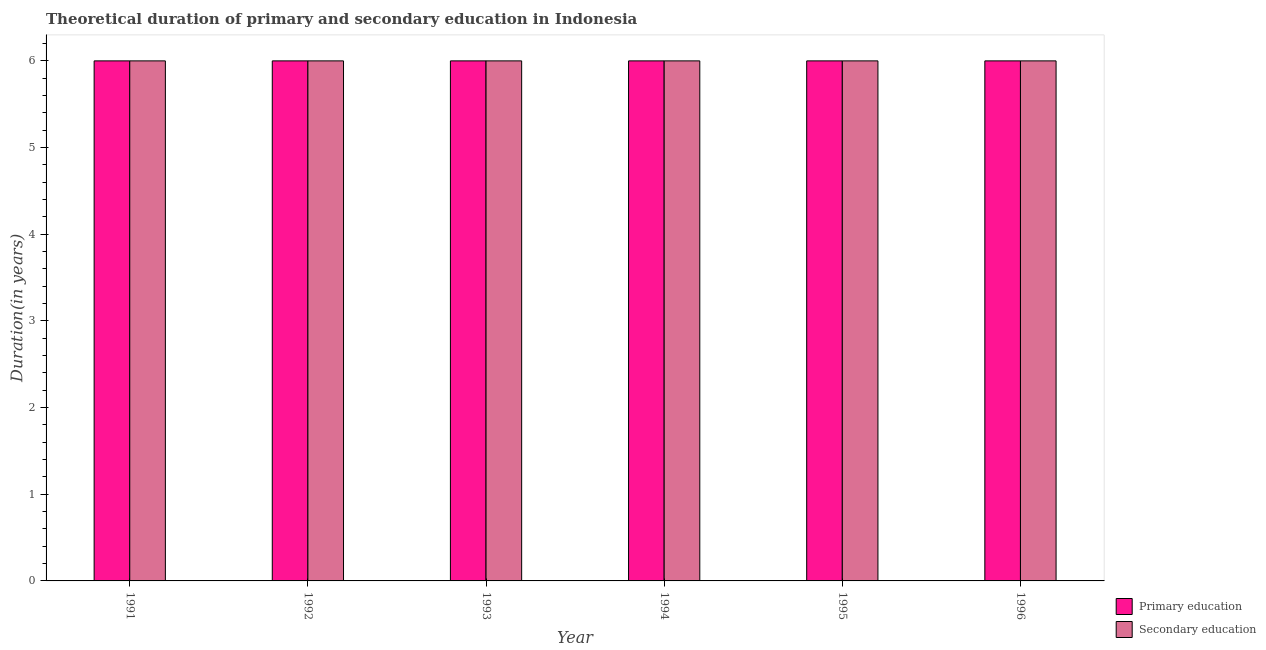How many groups of bars are there?
Keep it short and to the point. 6. Are the number of bars per tick equal to the number of legend labels?
Offer a very short reply. Yes. Are the number of bars on each tick of the X-axis equal?
Your answer should be compact. Yes. What is the label of the 5th group of bars from the left?
Your answer should be compact. 1995. Across all years, what is the maximum duration of secondary education?
Your answer should be very brief. 6. Across all years, what is the minimum duration of secondary education?
Provide a short and direct response. 6. In which year was the duration of primary education maximum?
Your response must be concise. 1991. In which year was the duration of secondary education minimum?
Offer a terse response. 1991. What is the total duration of secondary education in the graph?
Provide a succinct answer. 36. What is the difference between the duration of secondary education in 1995 and that in 1996?
Provide a succinct answer. 0. In how many years, is the duration of secondary education greater than 3.2 years?
Give a very brief answer. 6. What is the difference between the highest and the second highest duration of primary education?
Ensure brevity in your answer.  0. What is the difference between the highest and the lowest duration of primary education?
Ensure brevity in your answer.  0. In how many years, is the duration of primary education greater than the average duration of primary education taken over all years?
Your answer should be compact. 0. What does the 2nd bar from the left in 1992 represents?
Ensure brevity in your answer.  Secondary education. What does the 2nd bar from the right in 1992 represents?
Your answer should be very brief. Primary education. How many bars are there?
Your answer should be compact. 12. How many years are there in the graph?
Give a very brief answer. 6. What is the difference between two consecutive major ticks on the Y-axis?
Your answer should be compact. 1. Does the graph contain grids?
Make the answer very short. No. Where does the legend appear in the graph?
Give a very brief answer. Bottom right. How many legend labels are there?
Your response must be concise. 2. How are the legend labels stacked?
Ensure brevity in your answer.  Vertical. What is the title of the graph?
Keep it short and to the point. Theoretical duration of primary and secondary education in Indonesia. Does "Official creditors" appear as one of the legend labels in the graph?
Provide a succinct answer. No. What is the label or title of the X-axis?
Keep it short and to the point. Year. What is the label or title of the Y-axis?
Keep it short and to the point. Duration(in years). What is the Duration(in years) in Secondary education in 1991?
Give a very brief answer. 6. What is the Duration(in years) in Primary education in 1992?
Ensure brevity in your answer.  6. What is the Duration(in years) in Primary education in 1994?
Your answer should be very brief. 6. What is the Duration(in years) of Secondary education in 1994?
Offer a very short reply. 6. What is the Duration(in years) of Secondary education in 1995?
Make the answer very short. 6. What is the Duration(in years) of Primary education in 1996?
Give a very brief answer. 6. What is the Duration(in years) of Secondary education in 1996?
Provide a short and direct response. 6. Across all years, what is the maximum Duration(in years) in Primary education?
Your answer should be compact. 6. Across all years, what is the minimum Duration(in years) in Secondary education?
Give a very brief answer. 6. What is the difference between the Duration(in years) of Primary education in 1991 and that in 1992?
Give a very brief answer. 0. What is the difference between the Duration(in years) in Secondary education in 1991 and that in 1993?
Provide a succinct answer. 0. What is the difference between the Duration(in years) of Primary education in 1991 and that in 1994?
Provide a succinct answer. 0. What is the difference between the Duration(in years) of Primary education in 1991 and that in 1995?
Your response must be concise. 0. What is the difference between the Duration(in years) of Secondary education in 1991 and that in 1995?
Your response must be concise. 0. What is the difference between the Duration(in years) in Secondary education in 1991 and that in 1996?
Your answer should be compact. 0. What is the difference between the Duration(in years) in Secondary education in 1992 and that in 1993?
Ensure brevity in your answer.  0. What is the difference between the Duration(in years) of Secondary education in 1992 and that in 1994?
Offer a terse response. 0. What is the difference between the Duration(in years) in Primary education in 1992 and that in 1995?
Offer a very short reply. 0. What is the difference between the Duration(in years) of Primary education in 1992 and that in 1996?
Offer a terse response. 0. What is the difference between the Duration(in years) of Secondary education in 1992 and that in 1996?
Give a very brief answer. 0. What is the difference between the Duration(in years) in Primary education in 1993 and that in 1994?
Keep it short and to the point. 0. What is the difference between the Duration(in years) of Secondary education in 1993 and that in 1994?
Keep it short and to the point. 0. What is the difference between the Duration(in years) in Primary education in 1993 and that in 1995?
Offer a very short reply. 0. What is the difference between the Duration(in years) of Secondary education in 1993 and that in 1995?
Offer a terse response. 0. What is the difference between the Duration(in years) of Primary education in 1993 and that in 1996?
Provide a succinct answer. 0. What is the difference between the Duration(in years) in Primary education in 1994 and that in 1995?
Provide a succinct answer. 0. What is the difference between the Duration(in years) of Secondary education in 1994 and that in 1995?
Provide a short and direct response. 0. What is the difference between the Duration(in years) in Primary education in 1994 and that in 1996?
Your answer should be compact. 0. What is the difference between the Duration(in years) of Primary education in 1991 and the Duration(in years) of Secondary education in 1995?
Offer a very short reply. 0. What is the difference between the Duration(in years) of Primary education in 1991 and the Duration(in years) of Secondary education in 1996?
Offer a terse response. 0. What is the difference between the Duration(in years) in Primary education in 1992 and the Duration(in years) in Secondary education in 1995?
Make the answer very short. 0. What is the difference between the Duration(in years) of Primary education in 1993 and the Duration(in years) of Secondary education in 1995?
Your response must be concise. 0. What is the difference between the Duration(in years) of Primary education in 1994 and the Duration(in years) of Secondary education in 1995?
Make the answer very short. 0. What is the difference between the Duration(in years) in Primary education in 1994 and the Duration(in years) in Secondary education in 1996?
Provide a short and direct response. 0. What is the difference between the Duration(in years) in Primary education in 1995 and the Duration(in years) in Secondary education in 1996?
Offer a very short reply. 0. In the year 1992, what is the difference between the Duration(in years) in Primary education and Duration(in years) in Secondary education?
Provide a short and direct response. 0. In the year 1993, what is the difference between the Duration(in years) of Primary education and Duration(in years) of Secondary education?
Keep it short and to the point. 0. In the year 1994, what is the difference between the Duration(in years) of Primary education and Duration(in years) of Secondary education?
Keep it short and to the point. 0. In the year 1995, what is the difference between the Duration(in years) in Primary education and Duration(in years) in Secondary education?
Provide a short and direct response. 0. In the year 1996, what is the difference between the Duration(in years) in Primary education and Duration(in years) in Secondary education?
Make the answer very short. 0. What is the ratio of the Duration(in years) in Primary education in 1991 to that in 1995?
Ensure brevity in your answer.  1. What is the ratio of the Duration(in years) in Primary education in 1991 to that in 1996?
Make the answer very short. 1. What is the ratio of the Duration(in years) of Secondary education in 1992 to that in 1993?
Your answer should be very brief. 1. What is the ratio of the Duration(in years) of Secondary education in 1992 to that in 1994?
Make the answer very short. 1. What is the ratio of the Duration(in years) of Primary education in 1992 to that in 1995?
Ensure brevity in your answer.  1. What is the ratio of the Duration(in years) of Secondary education in 1992 to that in 1995?
Your answer should be compact. 1. What is the ratio of the Duration(in years) of Secondary education in 1993 to that in 1994?
Your response must be concise. 1. What is the ratio of the Duration(in years) in Primary education in 1993 to that in 1995?
Your response must be concise. 1. What is the ratio of the Duration(in years) in Secondary education in 1993 to that in 1995?
Ensure brevity in your answer.  1. What is the ratio of the Duration(in years) in Primary education in 1993 to that in 1996?
Make the answer very short. 1. What is the ratio of the Duration(in years) of Secondary education in 1993 to that in 1996?
Your answer should be very brief. 1. What is the ratio of the Duration(in years) of Primary education in 1994 to that in 1995?
Provide a succinct answer. 1. What is the ratio of the Duration(in years) in Secondary education in 1994 to that in 1995?
Ensure brevity in your answer.  1. What is the ratio of the Duration(in years) in Secondary education in 1994 to that in 1996?
Give a very brief answer. 1. What is the ratio of the Duration(in years) of Primary education in 1995 to that in 1996?
Offer a very short reply. 1. What is the difference between the highest and the second highest Duration(in years) in Primary education?
Give a very brief answer. 0. What is the difference between the highest and the lowest Duration(in years) in Primary education?
Your answer should be very brief. 0. 